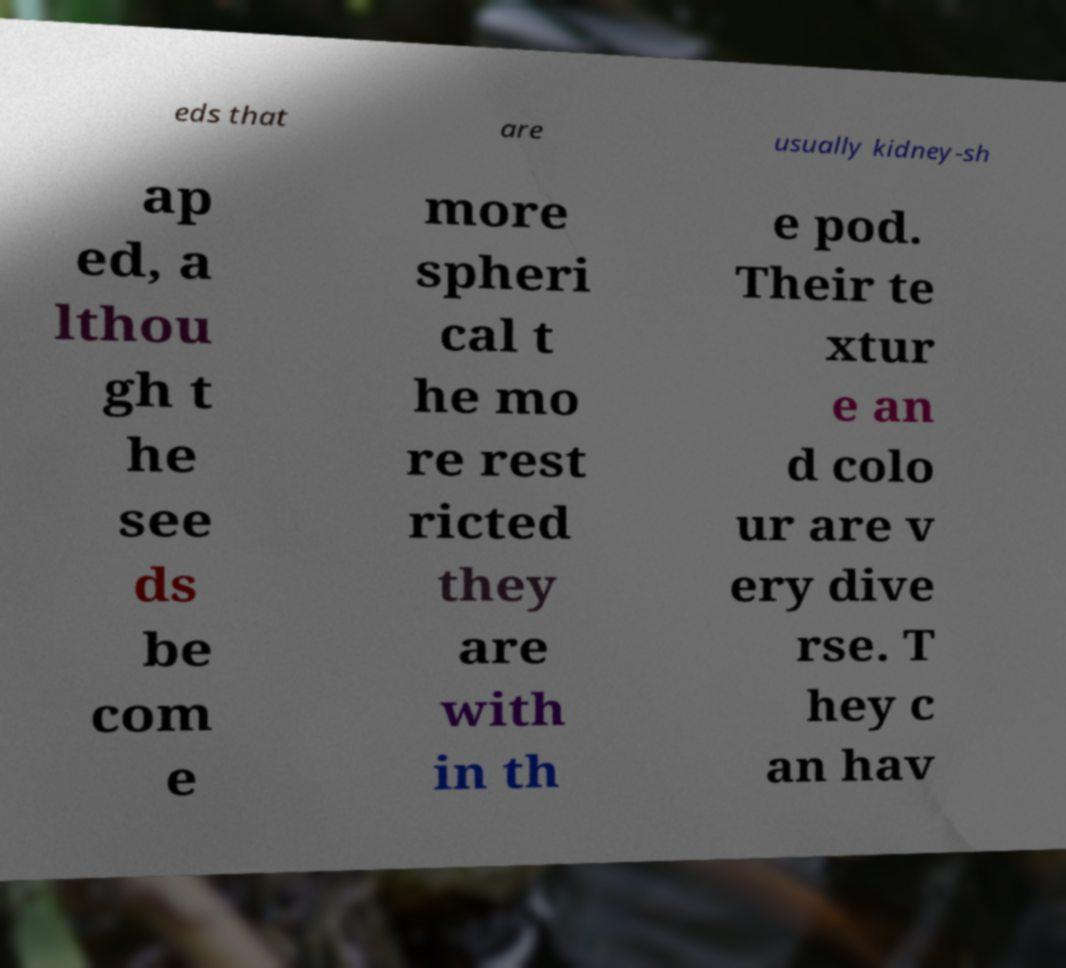There's text embedded in this image that I need extracted. Can you transcribe it verbatim? eds that are usually kidney-sh ap ed, a lthou gh t he see ds be com e more spheri cal t he mo re rest ricted they are with in th e pod. Their te xtur e an d colo ur are v ery dive rse. T hey c an hav 